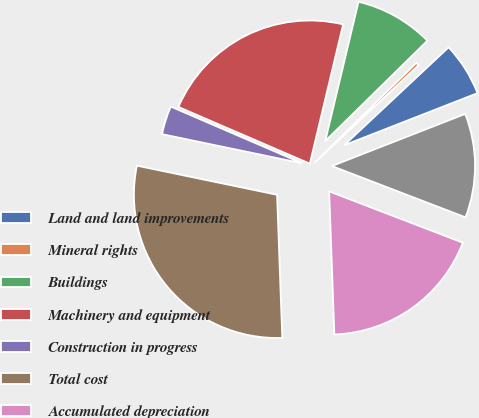Convert chart to OTSL. <chart><loc_0><loc_0><loc_500><loc_500><pie_chart><fcel>Land and land improvements<fcel>Mineral rights<fcel>Buildings<fcel>Machinery and equipment<fcel>Construction in progress<fcel>Total cost<fcel>Accumulated depreciation<fcel>Property plant and equipment<nl><fcel>6.06%<fcel>0.37%<fcel>8.91%<fcel>22.25%<fcel>3.22%<fcel>28.84%<fcel>18.59%<fcel>11.76%<nl></chart> 